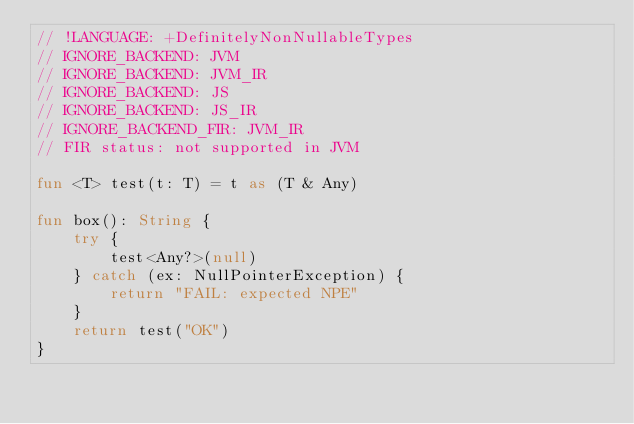Convert code to text. <code><loc_0><loc_0><loc_500><loc_500><_Kotlin_>// !LANGUAGE: +DefinitelyNonNullableTypes
// IGNORE_BACKEND: JVM
// IGNORE_BACKEND: JVM_IR
// IGNORE_BACKEND: JS
// IGNORE_BACKEND: JS_IR
// IGNORE_BACKEND_FIR: JVM_IR
// FIR status: not supported in JVM

fun <T> test(t: T) = t as (T & Any)

fun box(): String {
    try {
        test<Any?>(null)
    } catch (ex: NullPointerException) {
        return "FAIL: expected NPE"
    }
    return test("OK")
}</code> 